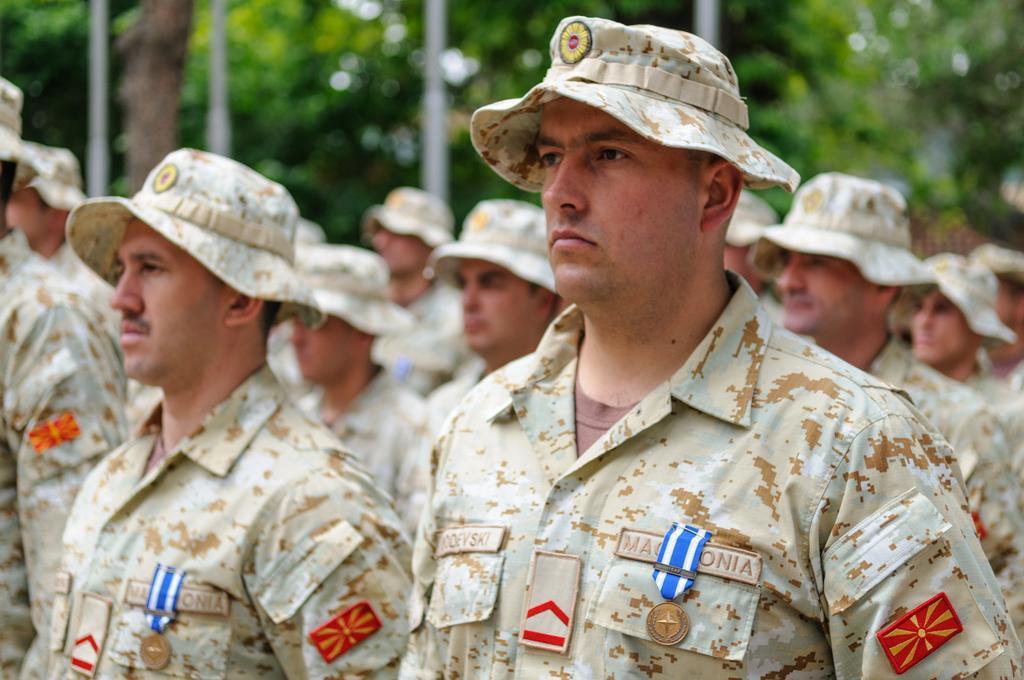Describe this image in one or two sentences. In this picture there are people in the center of the image and there are trees at the top side of the image. 